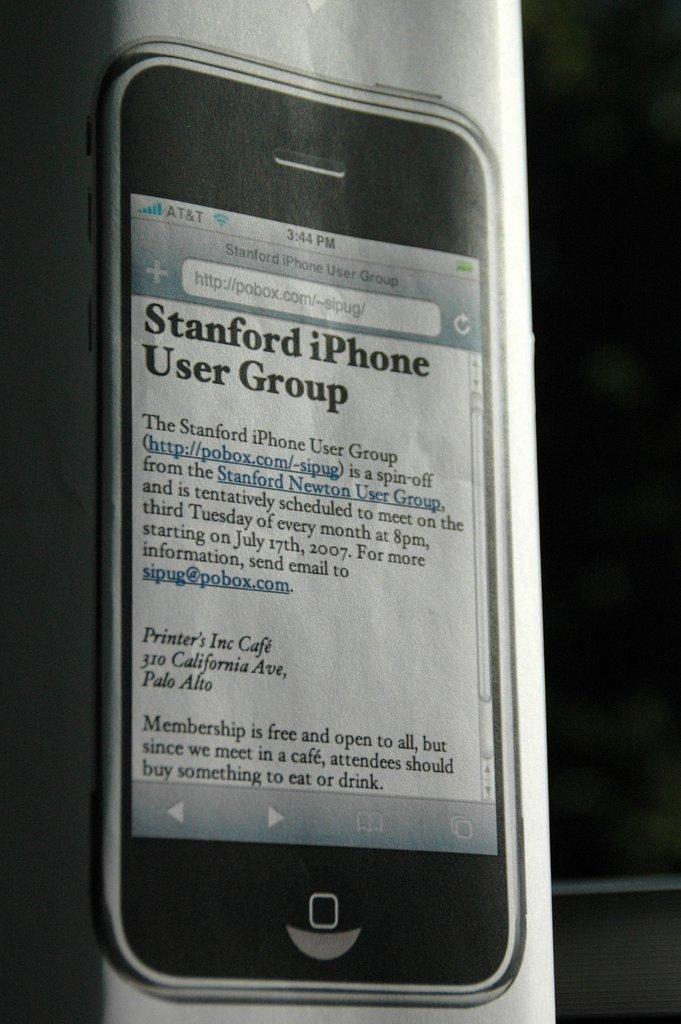Provide a one-sentence caption for the provided image. The article shown is from stanford iPhone user group. 